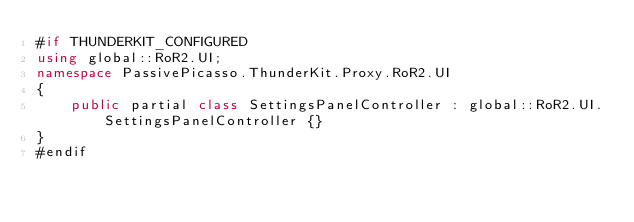<code> <loc_0><loc_0><loc_500><loc_500><_C#_>#if THUNDERKIT_CONFIGURED
using global::RoR2.UI;
namespace PassivePicasso.ThunderKit.Proxy.RoR2.UI
{
    public partial class SettingsPanelController : global::RoR2.UI.SettingsPanelController {}
}
#endif</code> 